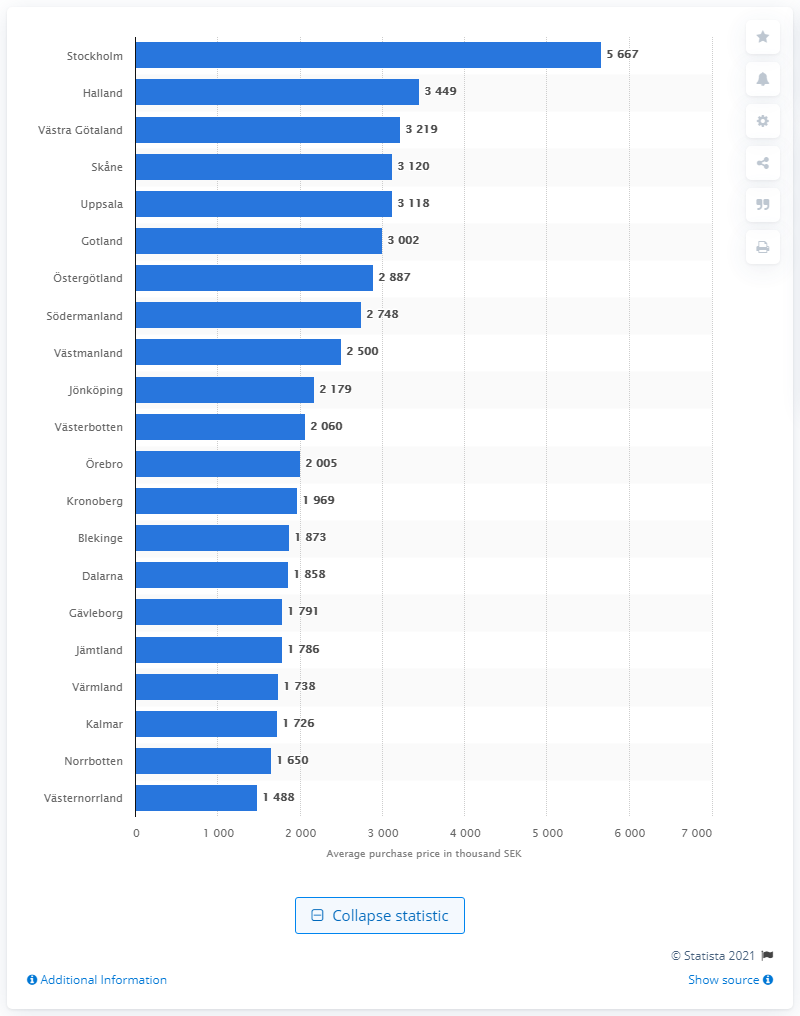Which region shows the lowest purchase price according to the image? Västernorrland shows the lowest average purchase price, with a value of 1,488 thousand SEK, according to the chart. 